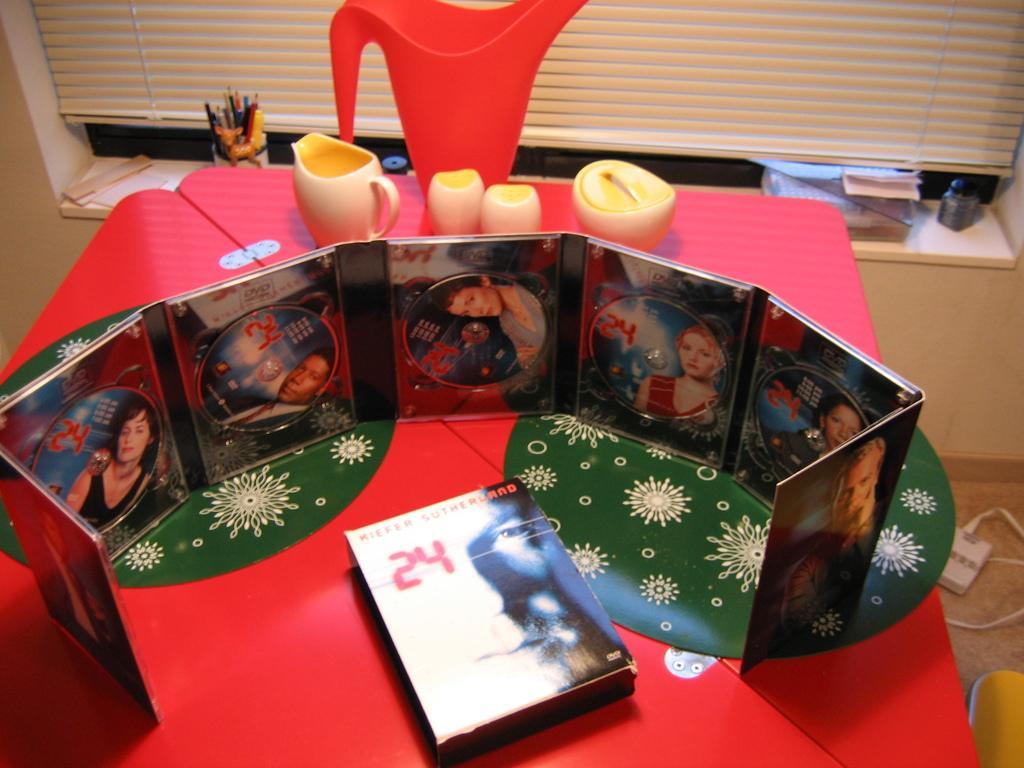How would you summarize this image in a sentence or two? In this image we can see there is a wall with a window. And there is a table, on the table there are photo frames arranged in an order. And at the back there are cups, jar, box, paper, pens and few objects. 